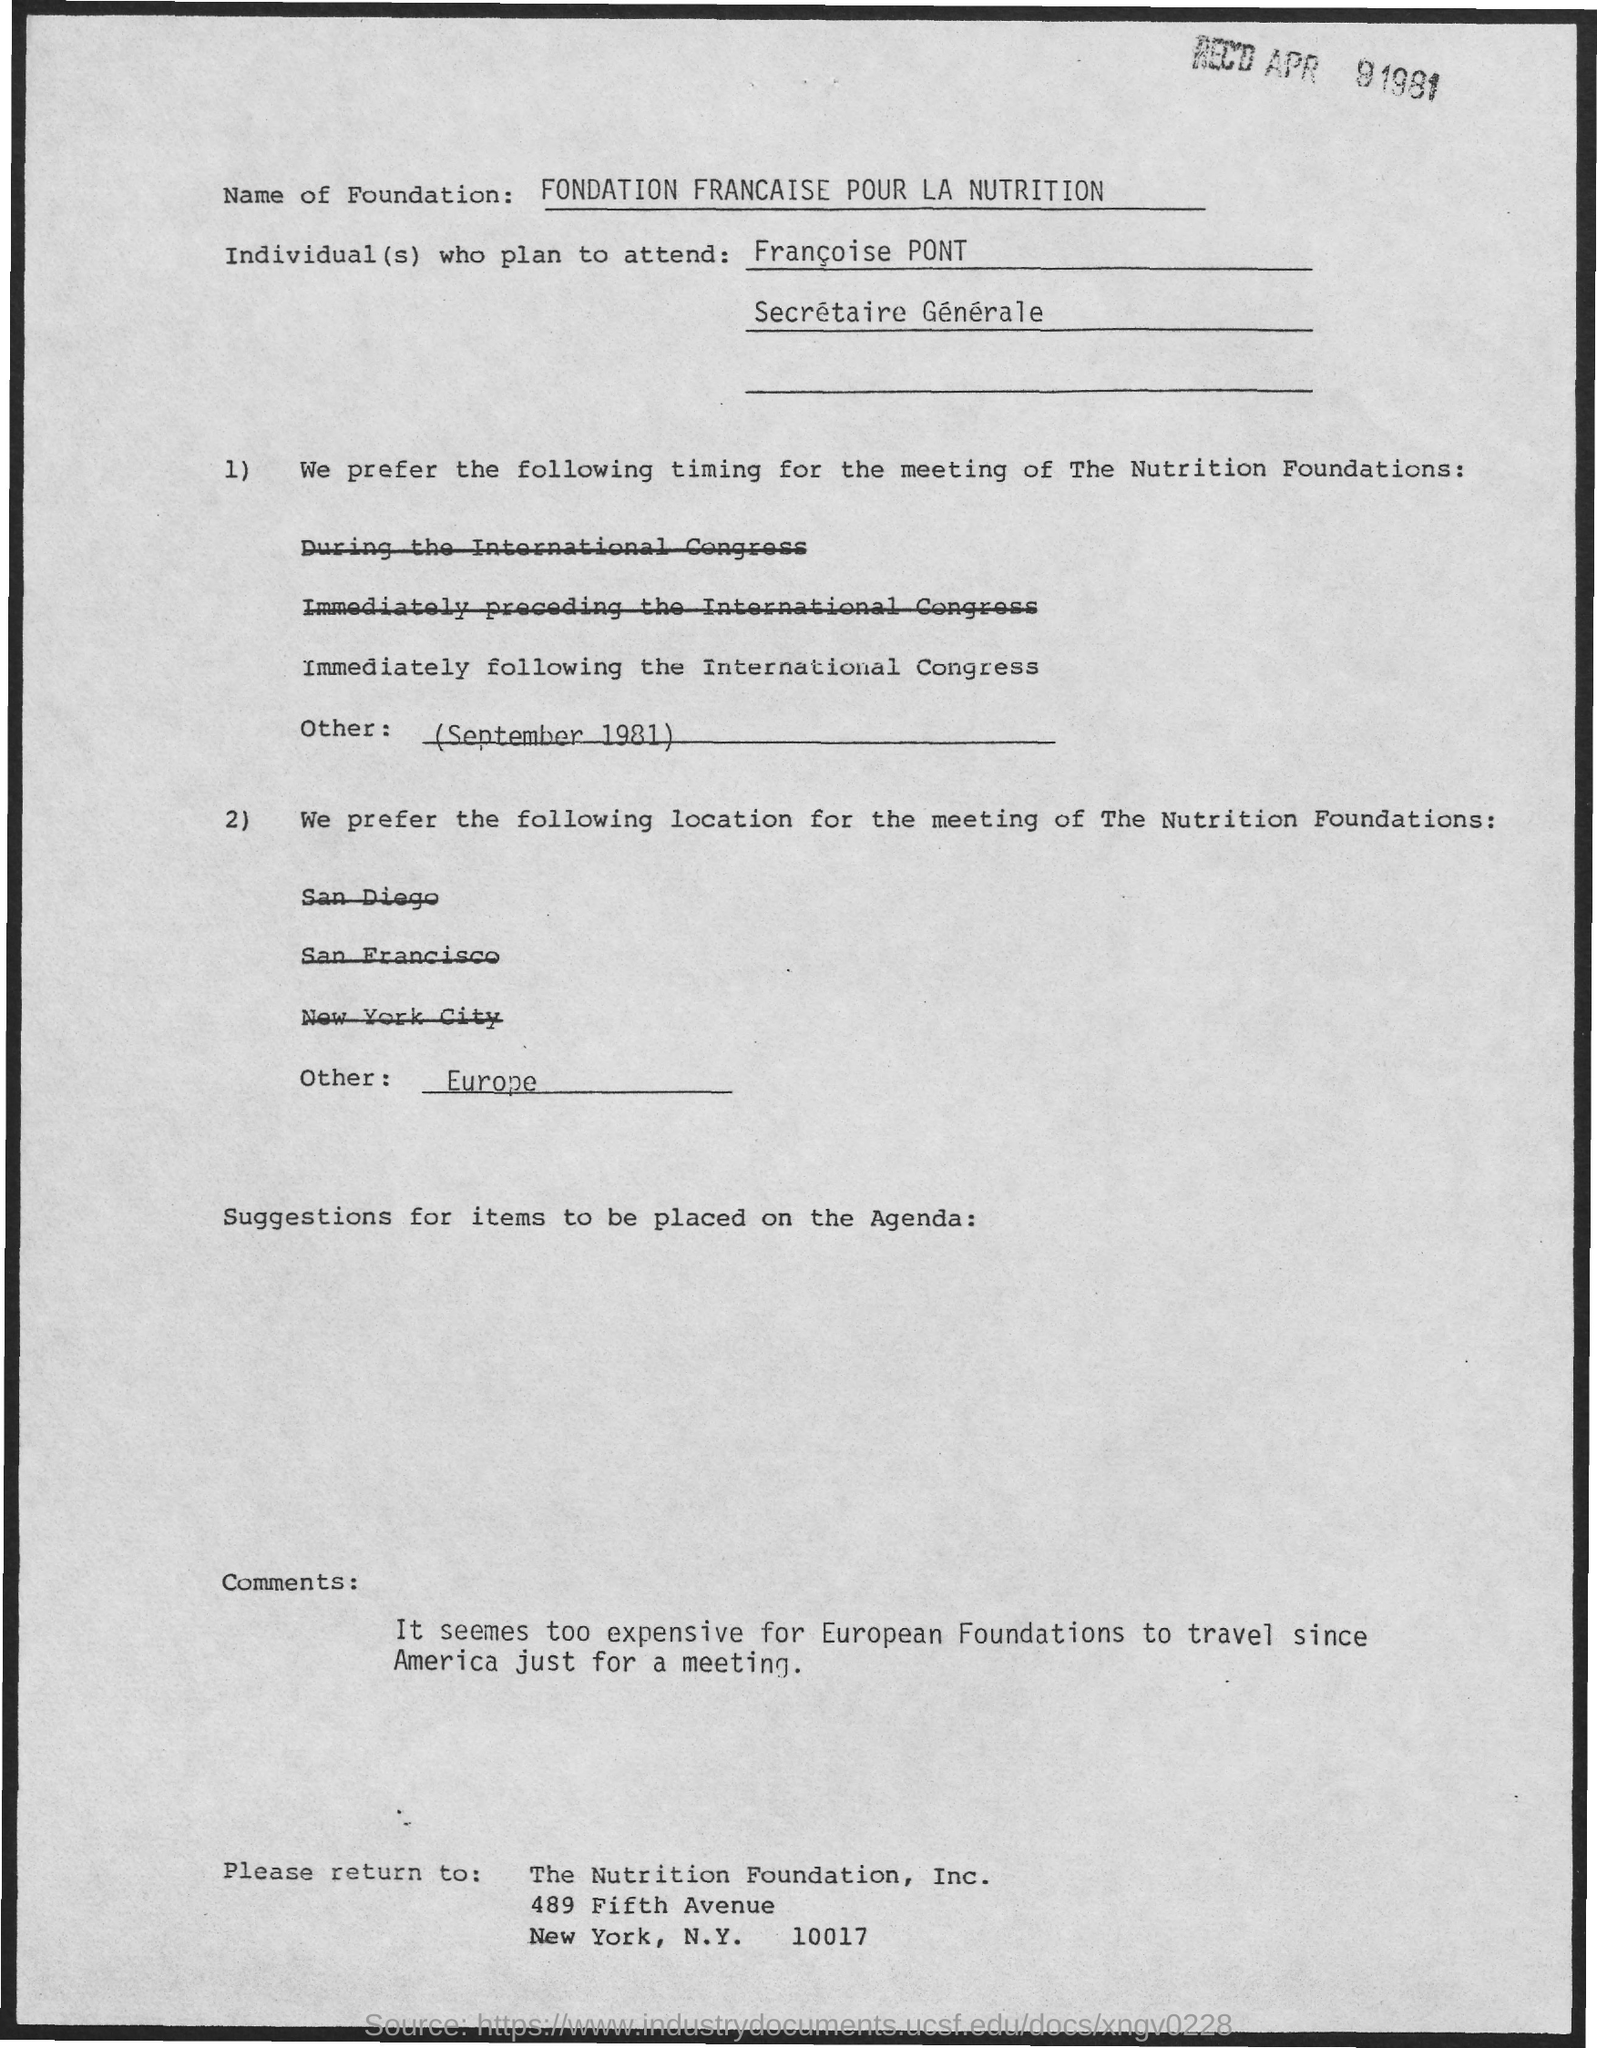Which is the preferred  location for the meeting of The Nutrition Foundations?
Your answer should be very brief. Europe. 